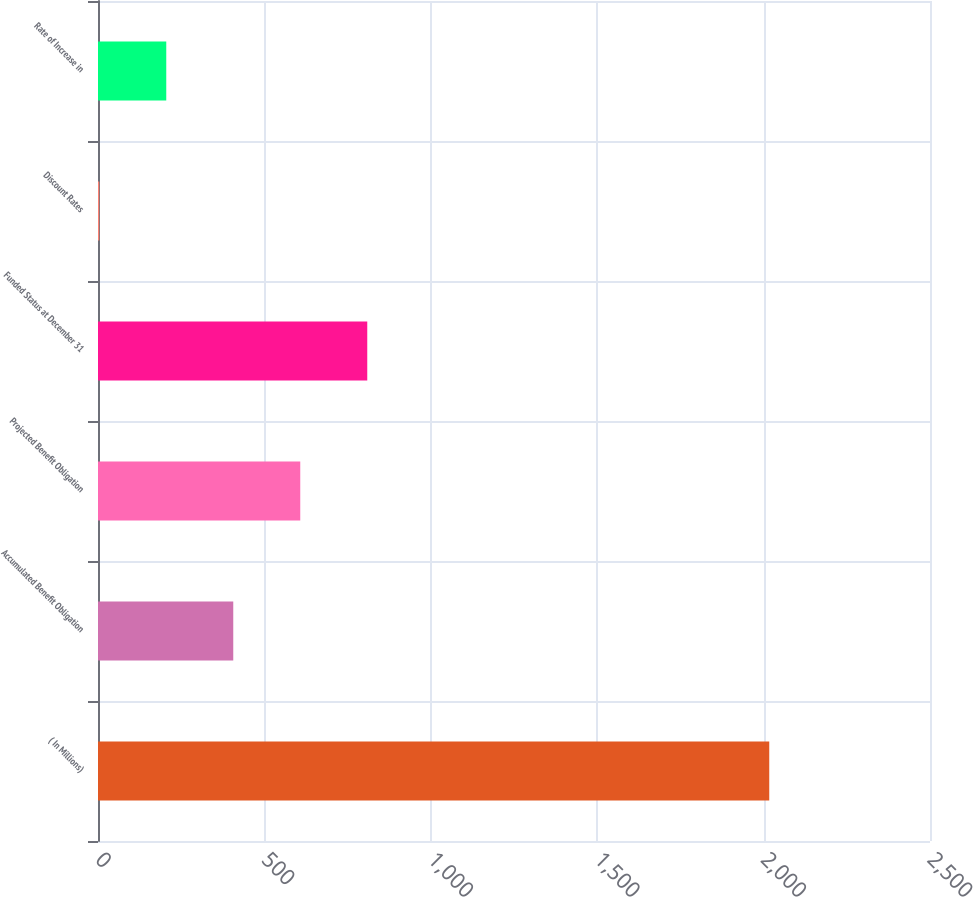Convert chart to OTSL. <chart><loc_0><loc_0><loc_500><loc_500><bar_chart><fcel>( In Millions)<fcel>Accumulated Benefit Obligation<fcel>Projected Benefit Obligation<fcel>Funded Status at December 31<fcel>Discount Rates<fcel>Rate of Increase in<nl><fcel>2017<fcel>406.43<fcel>607.75<fcel>809.07<fcel>3.79<fcel>205.11<nl></chart> 